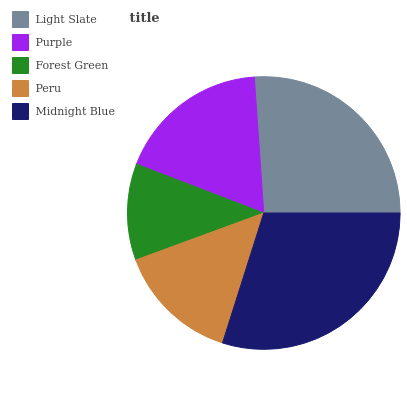Is Forest Green the minimum?
Answer yes or no. Yes. Is Midnight Blue the maximum?
Answer yes or no. Yes. Is Purple the minimum?
Answer yes or no. No. Is Purple the maximum?
Answer yes or no. No. Is Light Slate greater than Purple?
Answer yes or no. Yes. Is Purple less than Light Slate?
Answer yes or no. Yes. Is Purple greater than Light Slate?
Answer yes or no. No. Is Light Slate less than Purple?
Answer yes or no. No. Is Purple the high median?
Answer yes or no. Yes. Is Purple the low median?
Answer yes or no. Yes. Is Peru the high median?
Answer yes or no. No. Is Peru the low median?
Answer yes or no. No. 